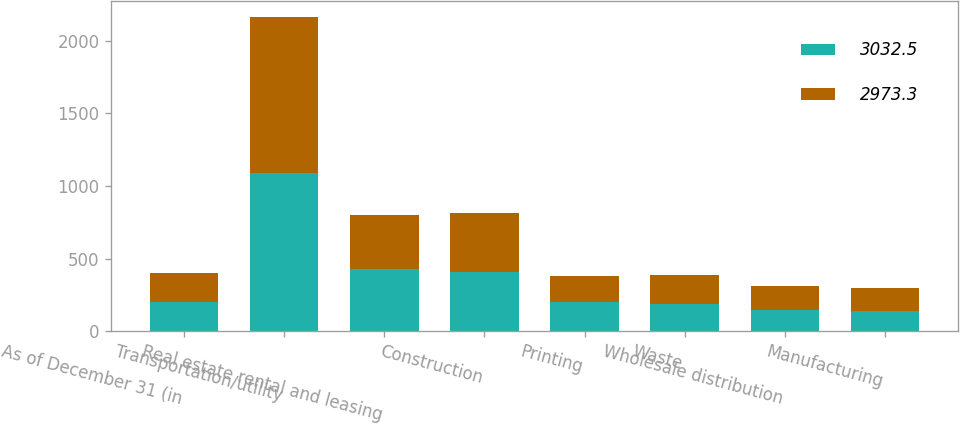Convert chart to OTSL. <chart><loc_0><loc_0><loc_500><loc_500><stacked_bar_chart><ecel><fcel>As of December 31 (in<fcel>Transportation/utility<fcel>Real estate rental and leasing<fcel>Construction<fcel>Printing<fcel>Waste<fcel>Wholesale distribution<fcel>Manufacturing<nl><fcel>3032.5<fcel>200.9<fcel>1088.3<fcel>427.9<fcel>410<fcel>197.8<fcel>186<fcel>145.8<fcel>139.7<nl><fcel>2973.3<fcel>200.9<fcel>1076.2<fcel>370<fcel>407.3<fcel>182<fcel>204<fcel>162.6<fcel>155.1<nl></chart> 